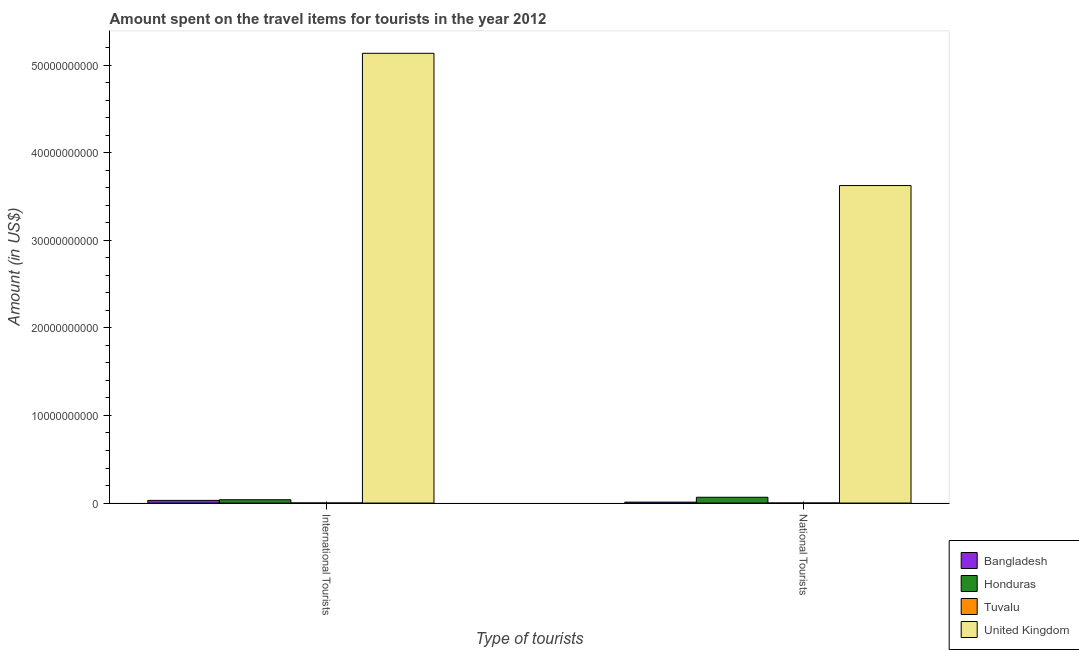How many groups of bars are there?
Give a very brief answer. 2. How many bars are there on the 1st tick from the left?
Offer a very short reply. 4. How many bars are there on the 2nd tick from the right?
Give a very brief answer. 4. What is the label of the 2nd group of bars from the left?
Give a very brief answer. National Tourists. What is the amount spent on travel items of international tourists in Tuvalu?
Offer a very short reply. 9.50e+06. Across all countries, what is the maximum amount spent on travel items of international tourists?
Give a very brief answer. 5.13e+1. Across all countries, what is the minimum amount spent on travel items of international tourists?
Your answer should be very brief. 9.50e+06. In which country was the amount spent on travel items of international tourists minimum?
Offer a very short reply. Tuvalu. What is the total amount spent on travel items of international tourists in the graph?
Offer a very short reply. 5.20e+1. What is the difference between the amount spent on travel items of national tourists in Honduras and that in Tuvalu?
Offer a terse response. 6.58e+08. What is the difference between the amount spent on travel items of international tourists in Tuvalu and the amount spent on travel items of national tourists in Honduras?
Ensure brevity in your answer.  -6.52e+08. What is the average amount spent on travel items of national tourists per country?
Your answer should be compact. 9.25e+09. What is the difference between the amount spent on travel items of international tourists and amount spent on travel items of national tourists in Tuvalu?
Give a very brief answer. 6.83e+06. In how many countries, is the amount spent on travel items of international tourists greater than 4000000000 US$?
Ensure brevity in your answer.  1. What is the ratio of the amount spent on travel items of national tourists in Honduras to that in Bangladesh?
Ensure brevity in your answer.  6.3. Is the amount spent on travel items of national tourists in Tuvalu less than that in Honduras?
Make the answer very short. Yes. What does the 1st bar from the right in International Tourists represents?
Keep it short and to the point. United Kingdom. How many bars are there?
Ensure brevity in your answer.  8. How many countries are there in the graph?
Offer a very short reply. 4. What is the difference between two consecutive major ticks on the Y-axis?
Your response must be concise. 1.00e+1. Does the graph contain grids?
Keep it short and to the point. No. Where does the legend appear in the graph?
Your answer should be very brief. Bottom right. How many legend labels are there?
Ensure brevity in your answer.  4. What is the title of the graph?
Ensure brevity in your answer.  Amount spent on the travel items for tourists in the year 2012. What is the label or title of the X-axis?
Give a very brief answer. Type of tourists. What is the label or title of the Y-axis?
Ensure brevity in your answer.  Amount (in US$). What is the Amount (in US$) in Bangladesh in International Tourists?
Give a very brief answer. 3.05e+08. What is the Amount (in US$) in Honduras in International Tourists?
Your response must be concise. 3.78e+08. What is the Amount (in US$) in Tuvalu in International Tourists?
Your response must be concise. 9.50e+06. What is the Amount (in US$) of United Kingdom in International Tourists?
Offer a terse response. 5.13e+1. What is the Amount (in US$) of Bangladesh in National Tourists?
Ensure brevity in your answer.  1.05e+08. What is the Amount (in US$) of Honduras in National Tourists?
Your response must be concise. 6.61e+08. What is the Amount (in US$) of Tuvalu in National Tourists?
Your answer should be very brief. 2.67e+06. What is the Amount (in US$) of United Kingdom in National Tourists?
Give a very brief answer. 3.62e+1. Across all Type of tourists, what is the maximum Amount (in US$) in Bangladesh?
Your answer should be compact. 3.05e+08. Across all Type of tourists, what is the maximum Amount (in US$) in Honduras?
Your response must be concise. 6.61e+08. Across all Type of tourists, what is the maximum Amount (in US$) in Tuvalu?
Ensure brevity in your answer.  9.50e+06. Across all Type of tourists, what is the maximum Amount (in US$) of United Kingdom?
Offer a very short reply. 5.13e+1. Across all Type of tourists, what is the minimum Amount (in US$) in Bangladesh?
Your answer should be very brief. 1.05e+08. Across all Type of tourists, what is the minimum Amount (in US$) in Honduras?
Make the answer very short. 3.78e+08. Across all Type of tourists, what is the minimum Amount (in US$) in Tuvalu?
Make the answer very short. 2.67e+06. Across all Type of tourists, what is the minimum Amount (in US$) of United Kingdom?
Give a very brief answer. 3.62e+1. What is the total Amount (in US$) of Bangladesh in the graph?
Make the answer very short. 4.10e+08. What is the total Amount (in US$) of Honduras in the graph?
Provide a succinct answer. 1.04e+09. What is the total Amount (in US$) in Tuvalu in the graph?
Ensure brevity in your answer.  1.22e+07. What is the total Amount (in US$) of United Kingdom in the graph?
Offer a terse response. 8.76e+1. What is the difference between the Amount (in US$) of Bangladesh in International Tourists and that in National Tourists?
Your answer should be very brief. 2.00e+08. What is the difference between the Amount (in US$) in Honduras in International Tourists and that in National Tourists?
Offer a very short reply. -2.83e+08. What is the difference between the Amount (in US$) in Tuvalu in International Tourists and that in National Tourists?
Offer a terse response. 6.83e+06. What is the difference between the Amount (in US$) of United Kingdom in International Tourists and that in National Tourists?
Give a very brief answer. 1.51e+1. What is the difference between the Amount (in US$) of Bangladesh in International Tourists and the Amount (in US$) of Honduras in National Tourists?
Provide a succinct answer. -3.56e+08. What is the difference between the Amount (in US$) in Bangladesh in International Tourists and the Amount (in US$) in Tuvalu in National Tourists?
Give a very brief answer. 3.02e+08. What is the difference between the Amount (in US$) of Bangladesh in International Tourists and the Amount (in US$) of United Kingdom in National Tourists?
Offer a very short reply. -3.59e+1. What is the difference between the Amount (in US$) in Honduras in International Tourists and the Amount (in US$) in Tuvalu in National Tourists?
Provide a succinct answer. 3.75e+08. What is the difference between the Amount (in US$) in Honduras in International Tourists and the Amount (in US$) in United Kingdom in National Tourists?
Keep it short and to the point. -3.59e+1. What is the difference between the Amount (in US$) of Tuvalu in International Tourists and the Amount (in US$) of United Kingdom in National Tourists?
Provide a short and direct response. -3.62e+1. What is the average Amount (in US$) in Bangladesh per Type of tourists?
Provide a succinct answer. 2.05e+08. What is the average Amount (in US$) of Honduras per Type of tourists?
Your response must be concise. 5.20e+08. What is the average Amount (in US$) in Tuvalu per Type of tourists?
Keep it short and to the point. 6.08e+06. What is the average Amount (in US$) in United Kingdom per Type of tourists?
Offer a very short reply. 4.38e+1. What is the difference between the Amount (in US$) in Bangladesh and Amount (in US$) in Honduras in International Tourists?
Offer a very short reply. -7.30e+07. What is the difference between the Amount (in US$) of Bangladesh and Amount (in US$) of Tuvalu in International Tourists?
Your response must be concise. 2.96e+08. What is the difference between the Amount (in US$) in Bangladesh and Amount (in US$) in United Kingdom in International Tourists?
Your answer should be very brief. -5.10e+1. What is the difference between the Amount (in US$) in Honduras and Amount (in US$) in Tuvalu in International Tourists?
Your answer should be very brief. 3.68e+08. What is the difference between the Amount (in US$) in Honduras and Amount (in US$) in United Kingdom in International Tourists?
Your answer should be compact. -5.10e+1. What is the difference between the Amount (in US$) of Tuvalu and Amount (in US$) of United Kingdom in International Tourists?
Ensure brevity in your answer.  -5.13e+1. What is the difference between the Amount (in US$) in Bangladesh and Amount (in US$) in Honduras in National Tourists?
Offer a very short reply. -5.56e+08. What is the difference between the Amount (in US$) of Bangladesh and Amount (in US$) of Tuvalu in National Tourists?
Provide a succinct answer. 1.02e+08. What is the difference between the Amount (in US$) of Bangladesh and Amount (in US$) of United Kingdom in National Tourists?
Offer a terse response. -3.61e+1. What is the difference between the Amount (in US$) of Honduras and Amount (in US$) of Tuvalu in National Tourists?
Offer a very short reply. 6.58e+08. What is the difference between the Amount (in US$) in Honduras and Amount (in US$) in United Kingdom in National Tourists?
Offer a terse response. -3.56e+1. What is the difference between the Amount (in US$) of Tuvalu and Amount (in US$) of United Kingdom in National Tourists?
Give a very brief answer. -3.62e+1. What is the ratio of the Amount (in US$) in Bangladesh in International Tourists to that in National Tourists?
Offer a terse response. 2.9. What is the ratio of the Amount (in US$) in Honduras in International Tourists to that in National Tourists?
Offer a terse response. 0.57. What is the ratio of the Amount (in US$) in Tuvalu in International Tourists to that in National Tourists?
Provide a short and direct response. 3.56. What is the ratio of the Amount (in US$) of United Kingdom in International Tourists to that in National Tourists?
Provide a succinct answer. 1.42. What is the difference between the highest and the second highest Amount (in US$) of Bangladesh?
Give a very brief answer. 2.00e+08. What is the difference between the highest and the second highest Amount (in US$) in Honduras?
Provide a short and direct response. 2.83e+08. What is the difference between the highest and the second highest Amount (in US$) of Tuvalu?
Offer a very short reply. 6.83e+06. What is the difference between the highest and the second highest Amount (in US$) in United Kingdom?
Your answer should be compact. 1.51e+1. What is the difference between the highest and the lowest Amount (in US$) in Honduras?
Provide a succinct answer. 2.83e+08. What is the difference between the highest and the lowest Amount (in US$) in Tuvalu?
Provide a short and direct response. 6.83e+06. What is the difference between the highest and the lowest Amount (in US$) in United Kingdom?
Provide a succinct answer. 1.51e+1. 